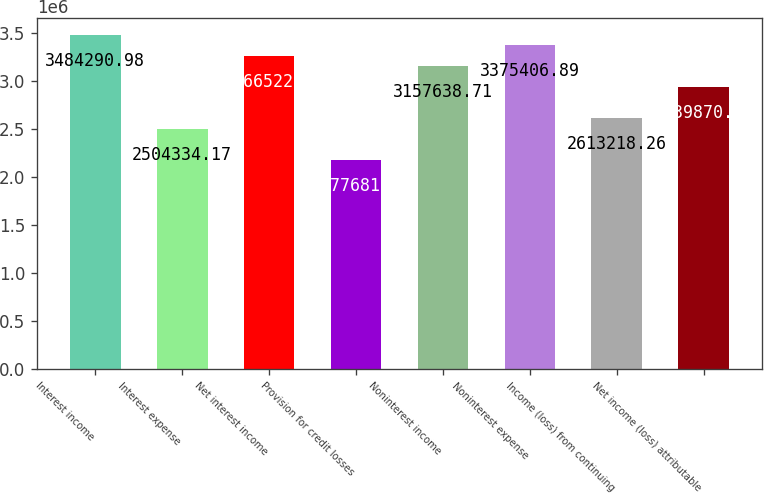Convert chart to OTSL. <chart><loc_0><loc_0><loc_500><loc_500><bar_chart><fcel>Interest income<fcel>Interest expense<fcel>Net interest income<fcel>Provision for credit losses<fcel>Noninterest income<fcel>Noninterest expense<fcel>Income (loss) from continuing<fcel>Net income (loss) attributable<nl><fcel>3.48429e+06<fcel>2.50433e+06<fcel>3.26652e+06<fcel>2.17768e+06<fcel>3.15764e+06<fcel>3.37541e+06<fcel>2.61322e+06<fcel>2.93987e+06<nl></chart> 